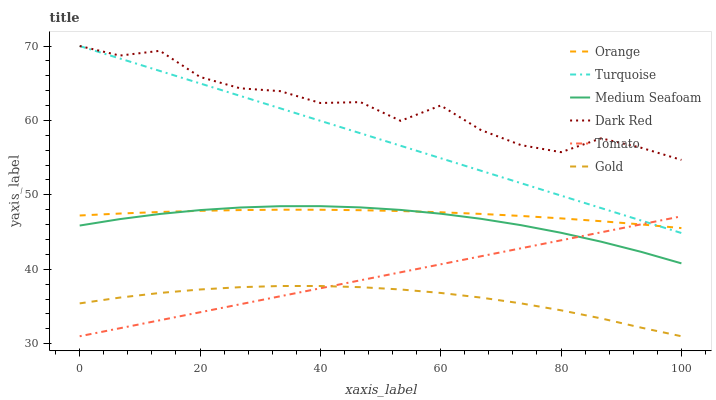Does Gold have the minimum area under the curve?
Answer yes or no. Yes. Does Dark Red have the maximum area under the curve?
Answer yes or no. Yes. Does Turquoise have the minimum area under the curve?
Answer yes or no. No. Does Turquoise have the maximum area under the curve?
Answer yes or no. No. Is Tomato the smoothest?
Answer yes or no. Yes. Is Dark Red the roughest?
Answer yes or no. Yes. Is Turquoise the smoothest?
Answer yes or no. No. Is Turquoise the roughest?
Answer yes or no. No. Does Turquoise have the lowest value?
Answer yes or no. No. Does Dark Red have the highest value?
Answer yes or no. Yes. Does Gold have the highest value?
Answer yes or no. No. Is Gold less than Orange?
Answer yes or no. Yes. Is Turquoise greater than Gold?
Answer yes or no. Yes. Does Orange intersect Tomato?
Answer yes or no. Yes. Is Orange less than Tomato?
Answer yes or no. No. Is Orange greater than Tomato?
Answer yes or no. No. Does Gold intersect Orange?
Answer yes or no. No. 